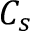<formula> <loc_0><loc_0><loc_500><loc_500>C _ { s }</formula> 